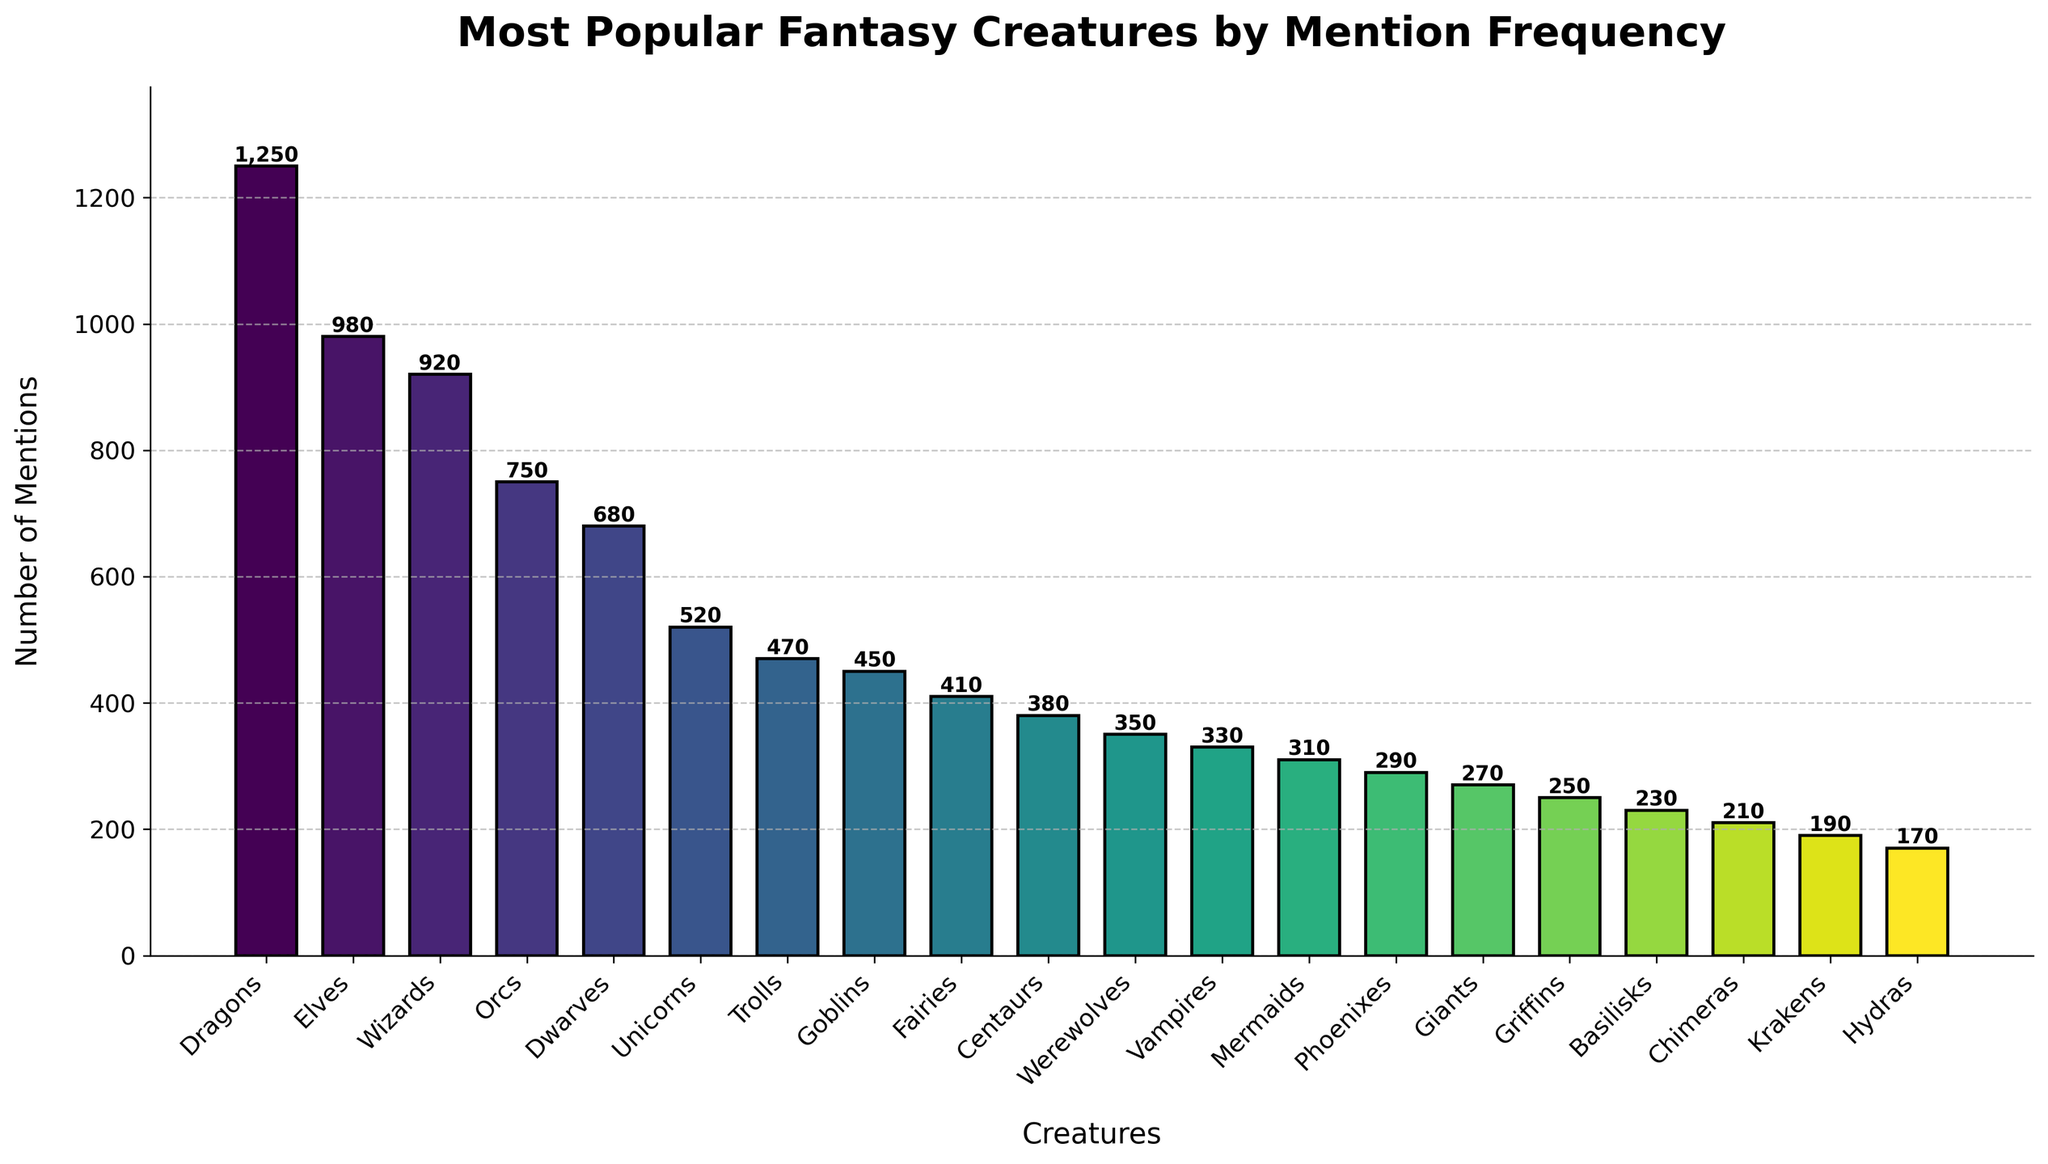What fantasy creature is mentioned most frequently? The tallest bar on the chart represents the creature with the highest number of mentions. This bar is the first and belongs to Dragons.
Answer: Dragons Which creature appears to be the least frequently mentioned? The shortest bar on the chart represents the creature with the least number of mentions. This bar is the last and belongs to Hydras.
Answer: Hydras How many more mentions do Elves have compared to Werewolves? The bar for Elves has 980 mentions and the bar for Werewolves has 350 mentions. The difference is calculated as 980 - 350.
Answer: 630 Which creature has more mentions: Goblins or Centaurs? By visually comparing the heights of the bars for Goblins and Centaurs, it is clear that Goblins have more mentions (450) than Centaurs (380).
Answer: Goblins What is the total number of mentions of Dwarves, Trolls, and Basilisks combined? Add the mentions for Dwarves (680), Trolls (470), and Basilisks (230). The sum is 680 + 470 + 230.
Answer: 1380 Are Unicorns mentioned more frequently than Vampires? Comparing the heights of the two bars, Unicorns (520 mentions) are mentioned more frequently than Vampires (330 mentions).
Answer: Yes What is the sum of the mentions for the three least mentioned creatures? The three least mentioned creatures are Hydras (170), Krakens (190), and Chimeras (210). Adding these together gives 170 + 190 + 210.
Answer: 570 How many creatures have more than 500 mentions? Count the bars that extend above the mark of 500 mentions: Dragons (1250), Elves (980), Wizards (920), Orcs (750), Dwarves (680), and Unicorns (520).
Answer: 6 What is the average number of mentions for the top five most mentioned creatures? The top five most mentioned creatures are Dragons (1250), Elves (980), Wizards (920), Orcs (750), and Dwarves (680). Sum these and divide by 5. (1250 + 980 + 920 + 750 + 680) / 5.
Answer: 916 How does the number of mentions for Fairies compare to the number of mentions for Phoenixes? The bar for Fairies has 410 mentions and for Phoenixes it has 290 mentions. Fairies have more mentions as indicated by the taller bar.
Answer: More 